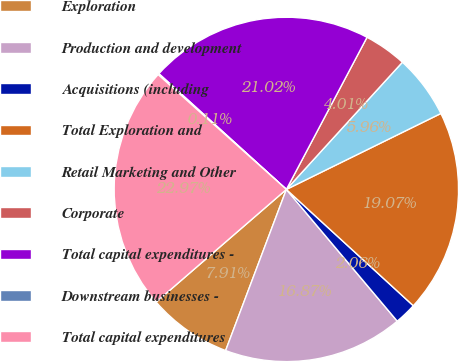<chart> <loc_0><loc_0><loc_500><loc_500><pie_chart><fcel>Exploration<fcel>Production and development<fcel>Acquisitions (including<fcel>Total Exploration and<fcel>Retail Marketing and Other<fcel>Corporate<fcel>Total capital expenditures -<fcel>Downstream businesses -<fcel>Total capital expenditures<nl><fcel>7.91%<fcel>16.87%<fcel>2.06%<fcel>19.07%<fcel>5.96%<fcel>4.01%<fcel>21.02%<fcel>0.11%<fcel>22.97%<nl></chart> 